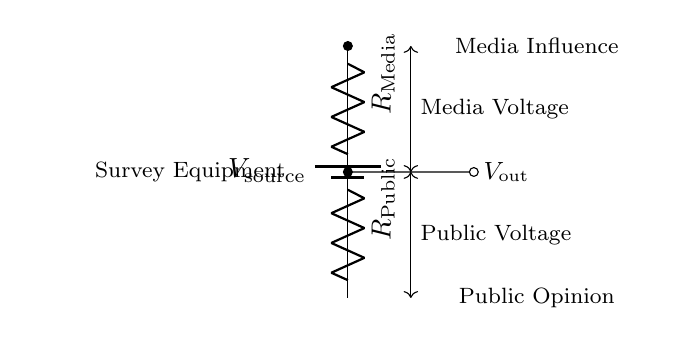What is the type of circuit depicted? The circuit depicted is a voltage divider, consisting of two resistors and a voltage source. A voltage divider is specifically designed to create a lower voltage from a higher voltage source by utilizing two or more resistors in series.
Answer: voltage divider What do the resistors represent in this context? The resistors, labeled as R Media and R Public, represent the influence of mass media and public opinion respectively, analyzing how these factors impact the output voltage in the survey equipment.
Answer: media and public opinion What is represented by the point labeled V out? The point labeled V out represents the output voltage, which is the voltage level indicating the public's perception influenced by media, derived from the applied source voltage.
Answer: output voltage How does the configuration of this circuit facilitate public opinion measurement? The voltage divider configuration allows for the scaling down of the source voltage based on the values of the resistors, effectively measuring how much of the media's influence (input voltage) affects the public opinion (output voltage).
Answer: by scaling the input voltage If R Media is twice the value of R Public, what is the voltage output ratio? In a voltage divider where R Media is twice R Public, the output voltage ratio would be one-third of the source voltage, calculating using voltage divider formula: V out = V source * (R Public / (R Media + R Public)).
Answer: one-third What does the distance between R Media and R Public imply? The distance or vertical positioning of R Media and R Public in the diagram visually represents their series connection, which is essential for the voltage division process, where the voltage is split proportionally based on resistance.
Answer: series connection What happens to V out if R Public is increased? If R Public is increased while keeping R Media constant, V out will increase as a larger portion of the source voltage will be across the increased resistor value, according to the voltage divider principle.
Answer: V out increases 